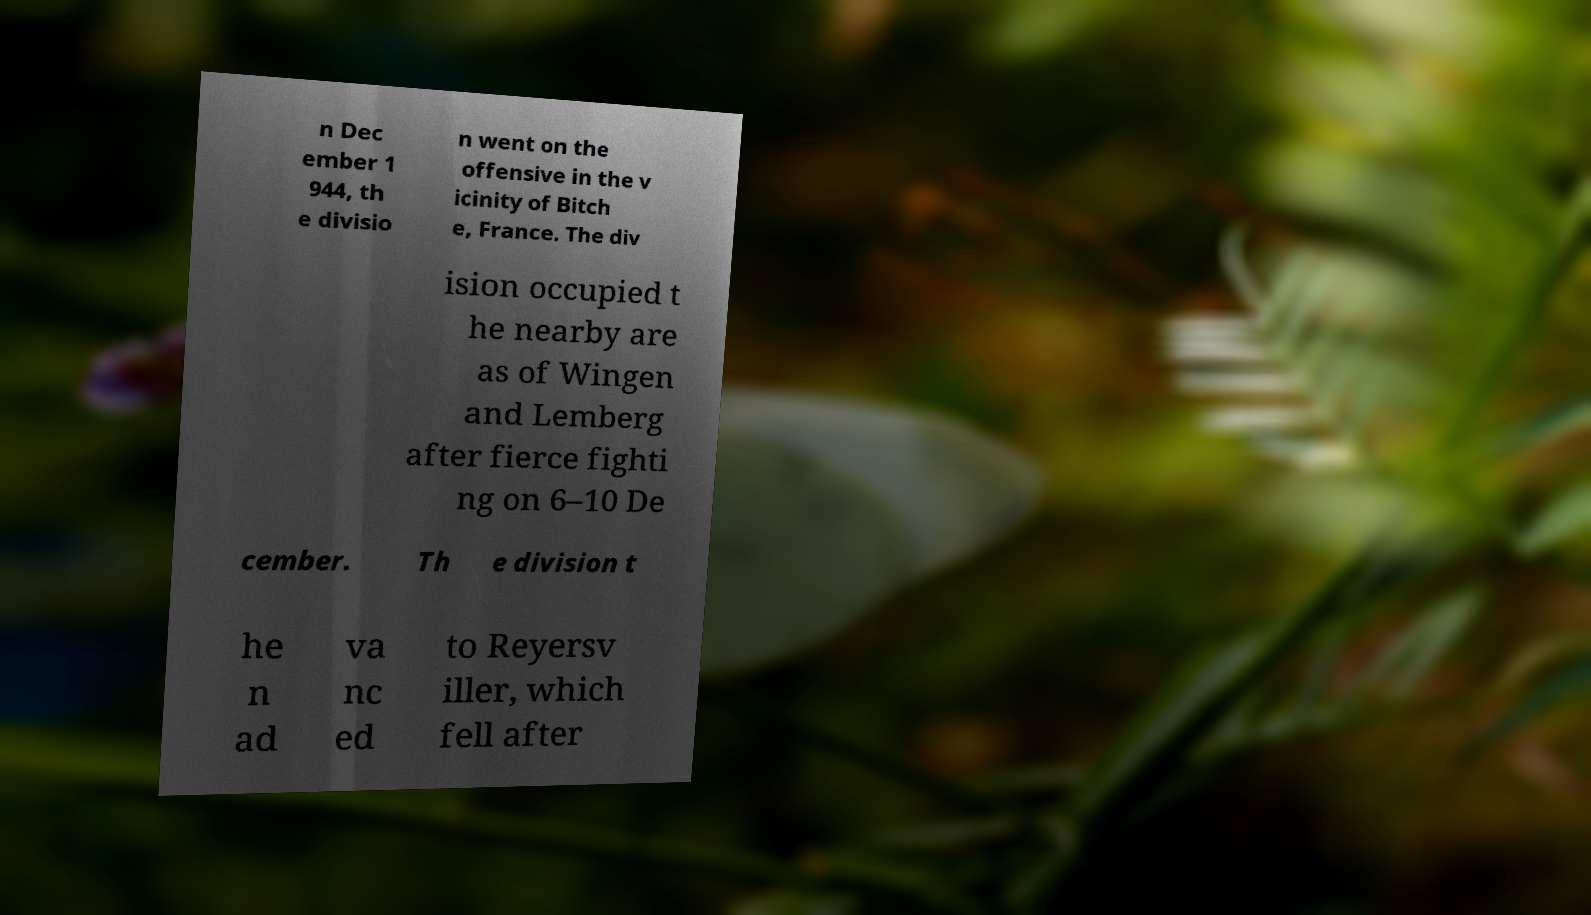Please identify and transcribe the text found in this image. n Dec ember 1 944, th e divisio n went on the offensive in the v icinity of Bitch e, France. The div ision occupied t he nearby are as of Wingen and Lemberg after fierce fighti ng on 6–10 De cember. Th e division t he n ad va nc ed to Reyersv iller, which fell after 